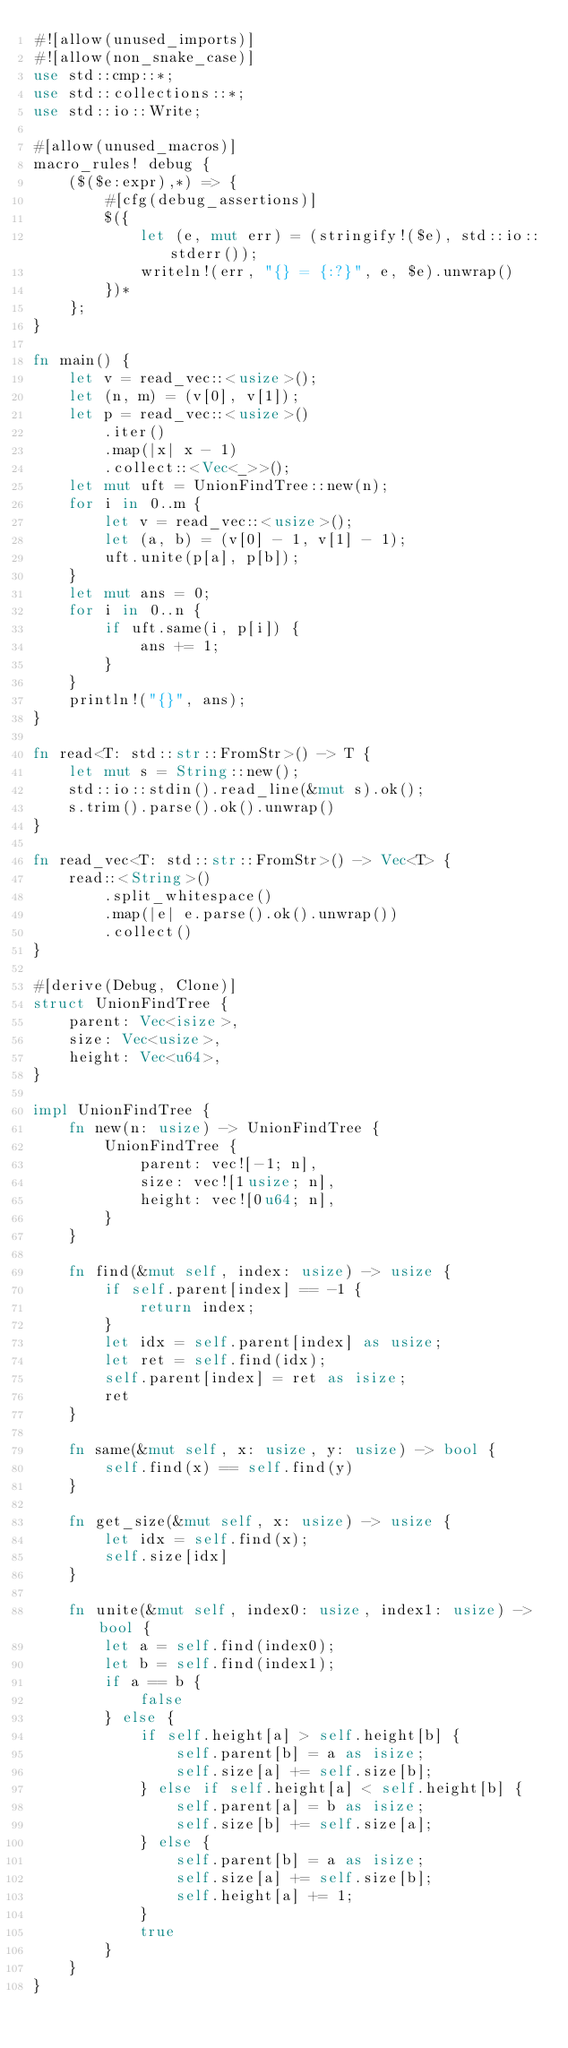Convert code to text. <code><loc_0><loc_0><loc_500><loc_500><_Rust_>#![allow(unused_imports)]
#![allow(non_snake_case)]
use std::cmp::*;
use std::collections::*;
use std::io::Write;

#[allow(unused_macros)]
macro_rules! debug {
    ($($e:expr),*) => {
        #[cfg(debug_assertions)]
        $({
            let (e, mut err) = (stringify!($e), std::io::stderr());
            writeln!(err, "{} = {:?}", e, $e).unwrap()
        })*
    };
}

fn main() {
    let v = read_vec::<usize>();
    let (n, m) = (v[0], v[1]);
    let p = read_vec::<usize>()
        .iter()
        .map(|x| x - 1)
        .collect::<Vec<_>>();
    let mut uft = UnionFindTree::new(n);
    for i in 0..m {
        let v = read_vec::<usize>();
        let (a, b) = (v[0] - 1, v[1] - 1);
        uft.unite(p[a], p[b]);
    }
    let mut ans = 0;
    for i in 0..n {
        if uft.same(i, p[i]) {
            ans += 1;
        }
    }
    println!("{}", ans);
}

fn read<T: std::str::FromStr>() -> T {
    let mut s = String::new();
    std::io::stdin().read_line(&mut s).ok();
    s.trim().parse().ok().unwrap()
}

fn read_vec<T: std::str::FromStr>() -> Vec<T> {
    read::<String>()
        .split_whitespace()
        .map(|e| e.parse().ok().unwrap())
        .collect()
}

#[derive(Debug, Clone)]
struct UnionFindTree {
    parent: Vec<isize>,
    size: Vec<usize>,
    height: Vec<u64>,
}

impl UnionFindTree {
    fn new(n: usize) -> UnionFindTree {
        UnionFindTree {
            parent: vec![-1; n],
            size: vec![1usize; n],
            height: vec![0u64; n],
        }
    }

    fn find(&mut self, index: usize) -> usize {
        if self.parent[index] == -1 {
            return index;
        }
        let idx = self.parent[index] as usize;
        let ret = self.find(idx);
        self.parent[index] = ret as isize;
        ret
    }

    fn same(&mut self, x: usize, y: usize) -> bool {
        self.find(x) == self.find(y)
    }

    fn get_size(&mut self, x: usize) -> usize {
        let idx = self.find(x);
        self.size[idx]
    }

    fn unite(&mut self, index0: usize, index1: usize) -> bool {
        let a = self.find(index0);
        let b = self.find(index1);
        if a == b {
            false
        } else {
            if self.height[a] > self.height[b] {
                self.parent[b] = a as isize;
                self.size[a] += self.size[b];
            } else if self.height[a] < self.height[b] {
                self.parent[a] = b as isize;
                self.size[b] += self.size[a];
            } else {
                self.parent[b] = a as isize;
                self.size[a] += self.size[b];
                self.height[a] += 1;
            }
            true
        }
    }
}
</code> 